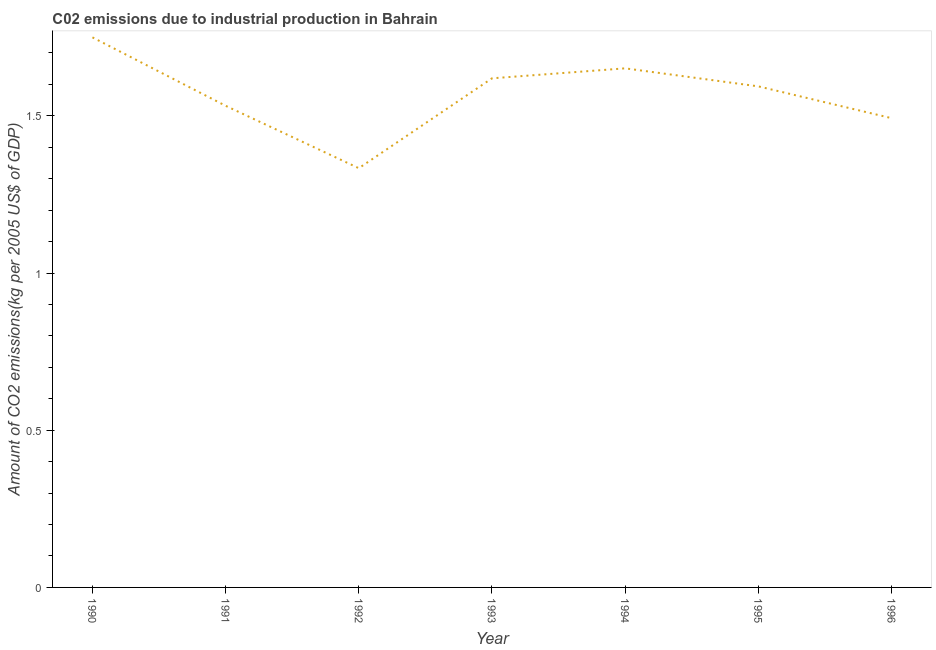What is the amount of co2 emissions in 1995?
Provide a short and direct response. 1.59. Across all years, what is the maximum amount of co2 emissions?
Offer a terse response. 1.75. Across all years, what is the minimum amount of co2 emissions?
Your response must be concise. 1.33. What is the sum of the amount of co2 emissions?
Your answer should be very brief. 10.97. What is the difference between the amount of co2 emissions in 1990 and 1992?
Offer a terse response. 0.42. What is the average amount of co2 emissions per year?
Your answer should be compact. 1.57. What is the median amount of co2 emissions?
Provide a short and direct response. 1.59. In how many years, is the amount of co2 emissions greater than 1.4 kg per 2005 US$ of GDP?
Keep it short and to the point. 6. What is the ratio of the amount of co2 emissions in 1993 to that in 1995?
Your answer should be very brief. 1.02. Is the difference between the amount of co2 emissions in 1991 and 1995 greater than the difference between any two years?
Your answer should be compact. No. What is the difference between the highest and the second highest amount of co2 emissions?
Provide a short and direct response. 0.1. What is the difference between the highest and the lowest amount of co2 emissions?
Your answer should be compact. 0.42. Does the amount of co2 emissions monotonically increase over the years?
Your response must be concise. No. Are the values on the major ticks of Y-axis written in scientific E-notation?
Give a very brief answer. No. Does the graph contain grids?
Provide a succinct answer. No. What is the title of the graph?
Give a very brief answer. C02 emissions due to industrial production in Bahrain. What is the label or title of the Y-axis?
Keep it short and to the point. Amount of CO2 emissions(kg per 2005 US$ of GDP). What is the Amount of CO2 emissions(kg per 2005 US$ of GDP) in 1990?
Give a very brief answer. 1.75. What is the Amount of CO2 emissions(kg per 2005 US$ of GDP) of 1991?
Your response must be concise. 1.53. What is the Amount of CO2 emissions(kg per 2005 US$ of GDP) of 1992?
Your response must be concise. 1.33. What is the Amount of CO2 emissions(kg per 2005 US$ of GDP) of 1993?
Provide a succinct answer. 1.62. What is the Amount of CO2 emissions(kg per 2005 US$ of GDP) of 1994?
Ensure brevity in your answer.  1.65. What is the Amount of CO2 emissions(kg per 2005 US$ of GDP) in 1995?
Your response must be concise. 1.59. What is the Amount of CO2 emissions(kg per 2005 US$ of GDP) in 1996?
Your answer should be very brief. 1.49. What is the difference between the Amount of CO2 emissions(kg per 2005 US$ of GDP) in 1990 and 1991?
Your answer should be compact. 0.22. What is the difference between the Amount of CO2 emissions(kg per 2005 US$ of GDP) in 1990 and 1992?
Your answer should be very brief. 0.42. What is the difference between the Amount of CO2 emissions(kg per 2005 US$ of GDP) in 1990 and 1993?
Keep it short and to the point. 0.13. What is the difference between the Amount of CO2 emissions(kg per 2005 US$ of GDP) in 1990 and 1994?
Give a very brief answer. 0.1. What is the difference between the Amount of CO2 emissions(kg per 2005 US$ of GDP) in 1990 and 1995?
Your answer should be very brief. 0.16. What is the difference between the Amount of CO2 emissions(kg per 2005 US$ of GDP) in 1990 and 1996?
Ensure brevity in your answer.  0.26. What is the difference between the Amount of CO2 emissions(kg per 2005 US$ of GDP) in 1991 and 1992?
Give a very brief answer. 0.2. What is the difference between the Amount of CO2 emissions(kg per 2005 US$ of GDP) in 1991 and 1993?
Give a very brief answer. -0.09. What is the difference between the Amount of CO2 emissions(kg per 2005 US$ of GDP) in 1991 and 1994?
Keep it short and to the point. -0.12. What is the difference between the Amount of CO2 emissions(kg per 2005 US$ of GDP) in 1991 and 1995?
Keep it short and to the point. -0.06. What is the difference between the Amount of CO2 emissions(kg per 2005 US$ of GDP) in 1991 and 1996?
Your answer should be compact. 0.04. What is the difference between the Amount of CO2 emissions(kg per 2005 US$ of GDP) in 1992 and 1993?
Make the answer very short. -0.29. What is the difference between the Amount of CO2 emissions(kg per 2005 US$ of GDP) in 1992 and 1994?
Ensure brevity in your answer.  -0.32. What is the difference between the Amount of CO2 emissions(kg per 2005 US$ of GDP) in 1992 and 1995?
Give a very brief answer. -0.26. What is the difference between the Amount of CO2 emissions(kg per 2005 US$ of GDP) in 1992 and 1996?
Make the answer very short. -0.16. What is the difference between the Amount of CO2 emissions(kg per 2005 US$ of GDP) in 1993 and 1994?
Keep it short and to the point. -0.03. What is the difference between the Amount of CO2 emissions(kg per 2005 US$ of GDP) in 1993 and 1995?
Keep it short and to the point. 0.03. What is the difference between the Amount of CO2 emissions(kg per 2005 US$ of GDP) in 1993 and 1996?
Ensure brevity in your answer.  0.13. What is the difference between the Amount of CO2 emissions(kg per 2005 US$ of GDP) in 1994 and 1995?
Provide a short and direct response. 0.06. What is the difference between the Amount of CO2 emissions(kg per 2005 US$ of GDP) in 1994 and 1996?
Provide a succinct answer. 0.16. What is the difference between the Amount of CO2 emissions(kg per 2005 US$ of GDP) in 1995 and 1996?
Make the answer very short. 0.1. What is the ratio of the Amount of CO2 emissions(kg per 2005 US$ of GDP) in 1990 to that in 1991?
Your response must be concise. 1.14. What is the ratio of the Amount of CO2 emissions(kg per 2005 US$ of GDP) in 1990 to that in 1992?
Provide a succinct answer. 1.31. What is the ratio of the Amount of CO2 emissions(kg per 2005 US$ of GDP) in 1990 to that in 1993?
Provide a short and direct response. 1.08. What is the ratio of the Amount of CO2 emissions(kg per 2005 US$ of GDP) in 1990 to that in 1994?
Your answer should be compact. 1.06. What is the ratio of the Amount of CO2 emissions(kg per 2005 US$ of GDP) in 1990 to that in 1995?
Your answer should be very brief. 1.1. What is the ratio of the Amount of CO2 emissions(kg per 2005 US$ of GDP) in 1990 to that in 1996?
Offer a terse response. 1.17. What is the ratio of the Amount of CO2 emissions(kg per 2005 US$ of GDP) in 1991 to that in 1992?
Provide a succinct answer. 1.15. What is the ratio of the Amount of CO2 emissions(kg per 2005 US$ of GDP) in 1991 to that in 1993?
Make the answer very short. 0.95. What is the ratio of the Amount of CO2 emissions(kg per 2005 US$ of GDP) in 1991 to that in 1994?
Give a very brief answer. 0.93. What is the ratio of the Amount of CO2 emissions(kg per 2005 US$ of GDP) in 1992 to that in 1993?
Provide a succinct answer. 0.82. What is the ratio of the Amount of CO2 emissions(kg per 2005 US$ of GDP) in 1992 to that in 1994?
Give a very brief answer. 0.81. What is the ratio of the Amount of CO2 emissions(kg per 2005 US$ of GDP) in 1992 to that in 1995?
Offer a very short reply. 0.84. What is the ratio of the Amount of CO2 emissions(kg per 2005 US$ of GDP) in 1992 to that in 1996?
Your answer should be very brief. 0.89. What is the ratio of the Amount of CO2 emissions(kg per 2005 US$ of GDP) in 1993 to that in 1994?
Give a very brief answer. 0.98. What is the ratio of the Amount of CO2 emissions(kg per 2005 US$ of GDP) in 1993 to that in 1996?
Your answer should be very brief. 1.08. What is the ratio of the Amount of CO2 emissions(kg per 2005 US$ of GDP) in 1994 to that in 1995?
Keep it short and to the point. 1.04. What is the ratio of the Amount of CO2 emissions(kg per 2005 US$ of GDP) in 1994 to that in 1996?
Offer a terse response. 1.11. What is the ratio of the Amount of CO2 emissions(kg per 2005 US$ of GDP) in 1995 to that in 1996?
Provide a short and direct response. 1.07. 